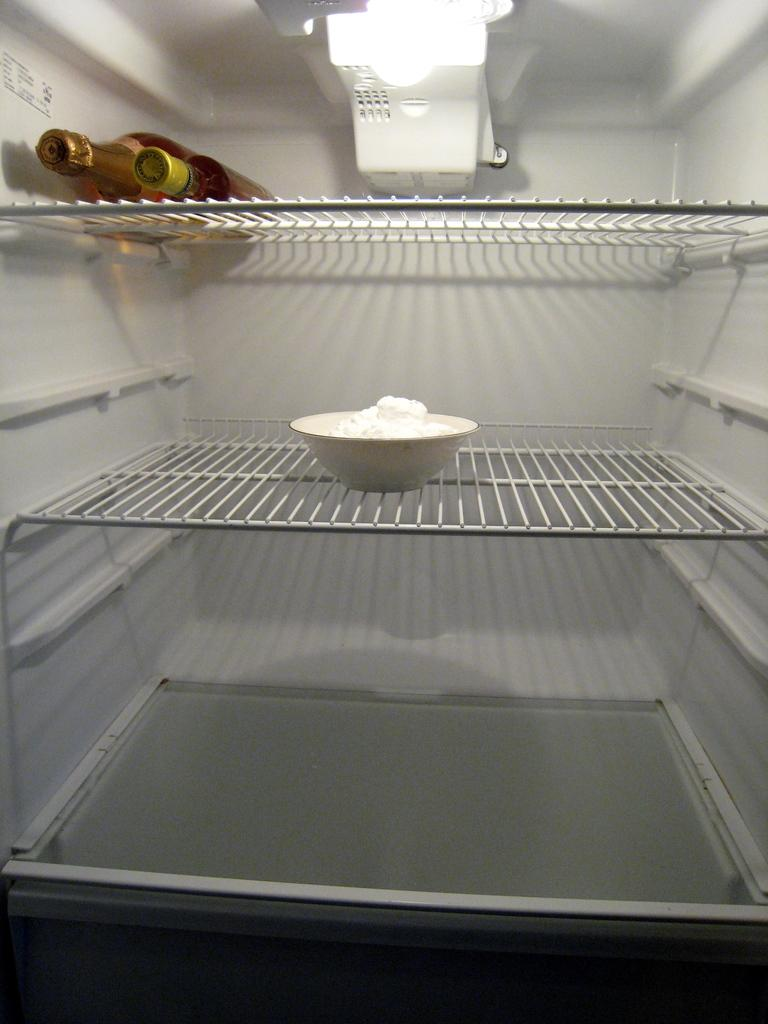What type of appliance is present in the image? There is a refrigerator in the image. What feature does the refrigerator have? The refrigerator has shelves. Is there any source of light inside the refrigerator? Yes, there is a light in the refrigerator. What can be found on one of the shelves in the refrigerator? There is a bowl with butter on one of the shelves. How many bottles are present in the refrigerator? There are two bottles in the refrigerator. How does the refrigerator help people connect with their pockets in the image? The refrigerator does not help people connect with their pockets in the image; it is an appliance for storing food and beverages. 